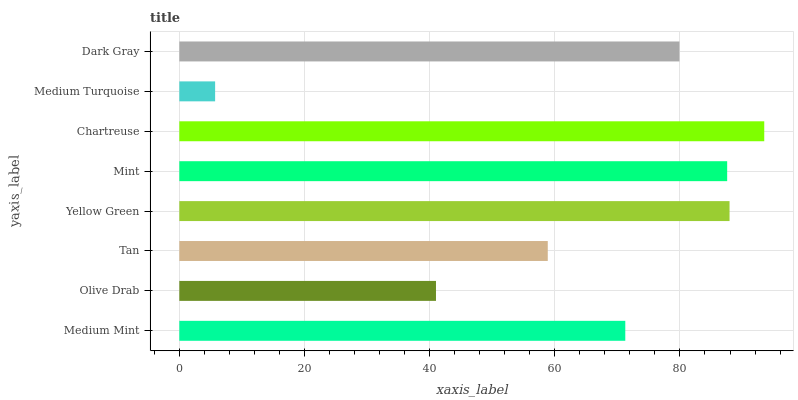Is Medium Turquoise the minimum?
Answer yes or no. Yes. Is Chartreuse the maximum?
Answer yes or no. Yes. Is Olive Drab the minimum?
Answer yes or no. No. Is Olive Drab the maximum?
Answer yes or no. No. Is Medium Mint greater than Olive Drab?
Answer yes or no. Yes. Is Olive Drab less than Medium Mint?
Answer yes or no. Yes. Is Olive Drab greater than Medium Mint?
Answer yes or no. No. Is Medium Mint less than Olive Drab?
Answer yes or no. No. Is Dark Gray the high median?
Answer yes or no. Yes. Is Medium Mint the low median?
Answer yes or no. Yes. Is Mint the high median?
Answer yes or no. No. Is Yellow Green the low median?
Answer yes or no. No. 